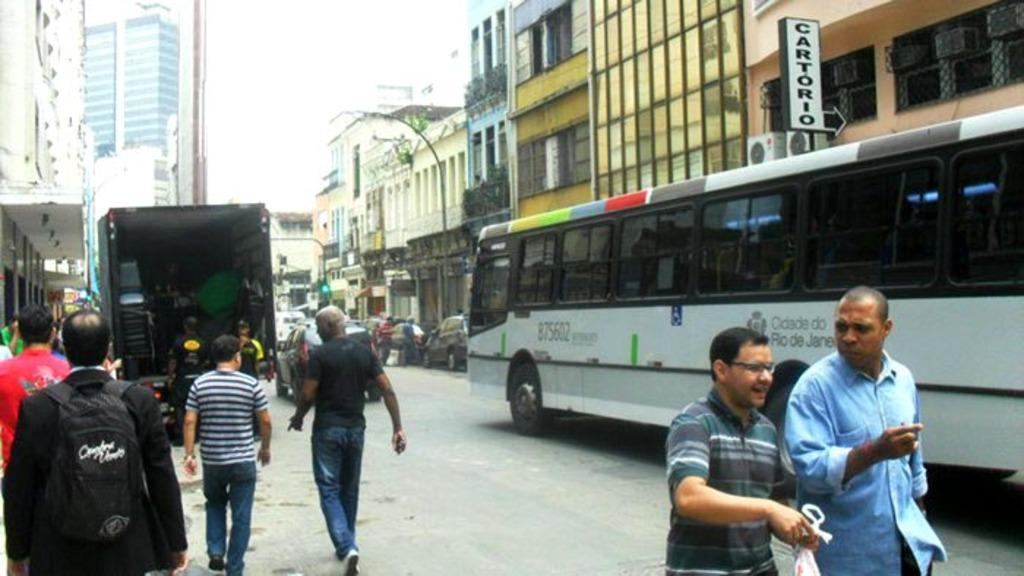Provide a one-sentence caption for the provided image. People walk down the street next to a bus that says Cidade Do Rio De Janeiro on its side. 